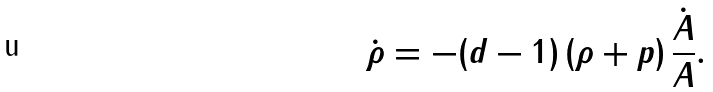Convert formula to latex. <formula><loc_0><loc_0><loc_500><loc_500>\dot { \rho } = - ( d - 1 ) \, ( \rho + p ) \, \frac { \dot { A } } { A } .</formula> 